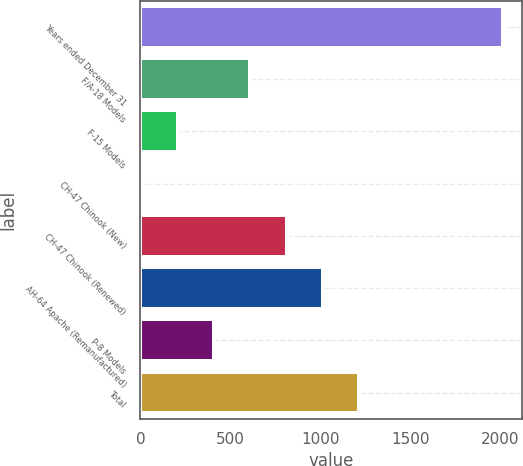Convert chart. <chart><loc_0><loc_0><loc_500><loc_500><bar_chart><fcel>Years ended December 31<fcel>F/A-18 Models<fcel>F-15 Models<fcel>CH-47 Chinook (New)<fcel>CH-47 Chinook (Renewed)<fcel>AH-64 Apache (Remanufactured)<fcel>P-8 Models<fcel>Total<nl><fcel>2017<fcel>611.4<fcel>209.8<fcel>9<fcel>812.2<fcel>1013<fcel>410.6<fcel>1213.8<nl></chart> 